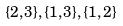<formula> <loc_0><loc_0><loc_500><loc_500>\{ 2 , 3 \} , \{ 1 , 3 \} , \{ 1 , 2 \}</formula> 